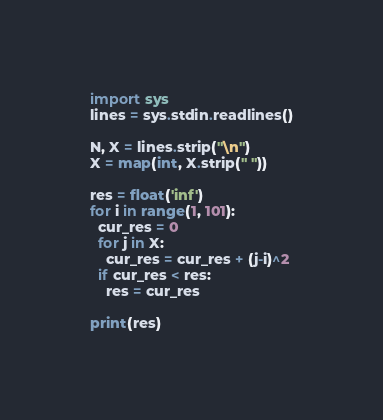<code> <loc_0><loc_0><loc_500><loc_500><_Python_>import sys
lines = sys.stdin.readlines()
 
N, X = lines.strip("\n")
X = map(int, X.strip(" "))
 
res = float('inf')
for i in range(1, 101):
  cur_res = 0
  for j in X:
    cur_res = cur_res + (j-i)^2
  if cur_res < res:
    res = cur_res
 
print(res)</code> 